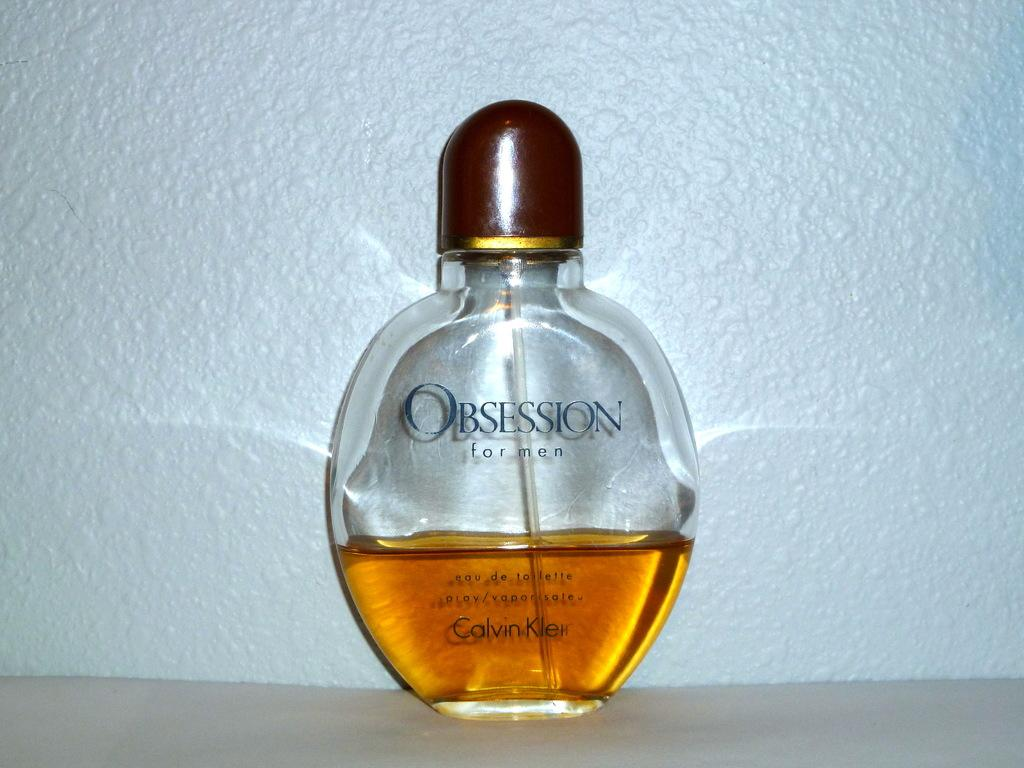<image>
Share a concise interpretation of the image provided. A bottle of Obsession by Calvin Klein is half empty. 